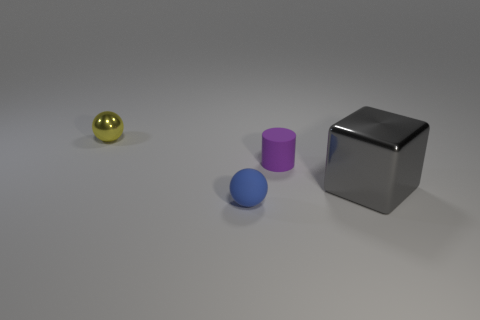Add 3 gray rubber cylinders. How many objects exist? 7 Subtract all cubes. How many objects are left? 3 Subtract 0 green blocks. How many objects are left? 4 Subtract all purple matte cubes. Subtract all large gray metal cubes. How many objects are left? 3 Add 4 metallic cubes. How many metallic cubes are left? 5 Add 3 small brown balls. How many small brown balls exist? 3 